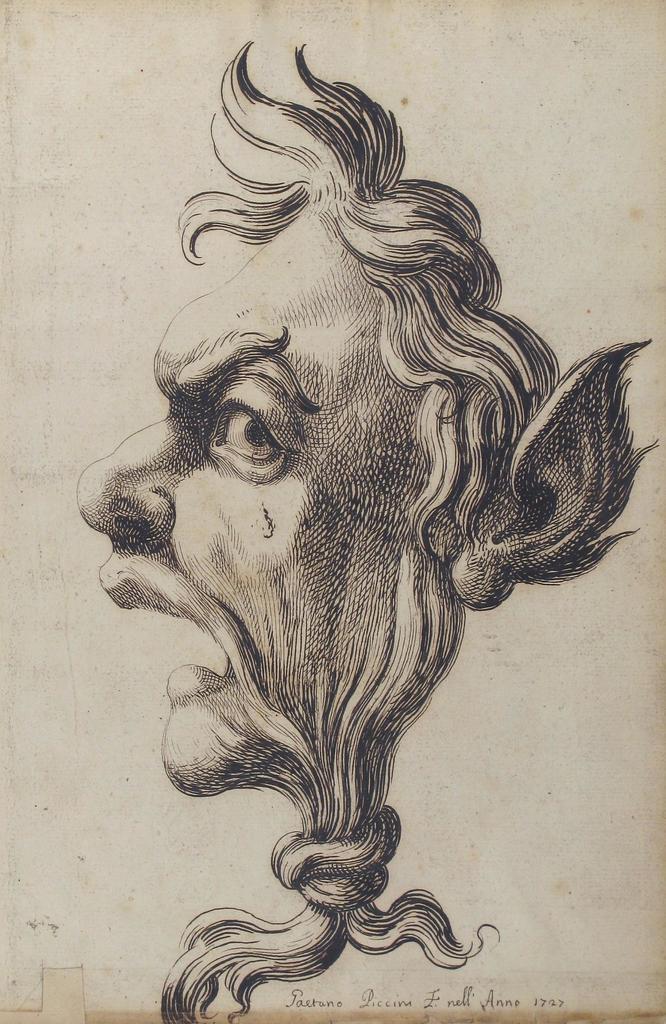Can you describe this image briefly? This image is a painting of the face which is in the center. 